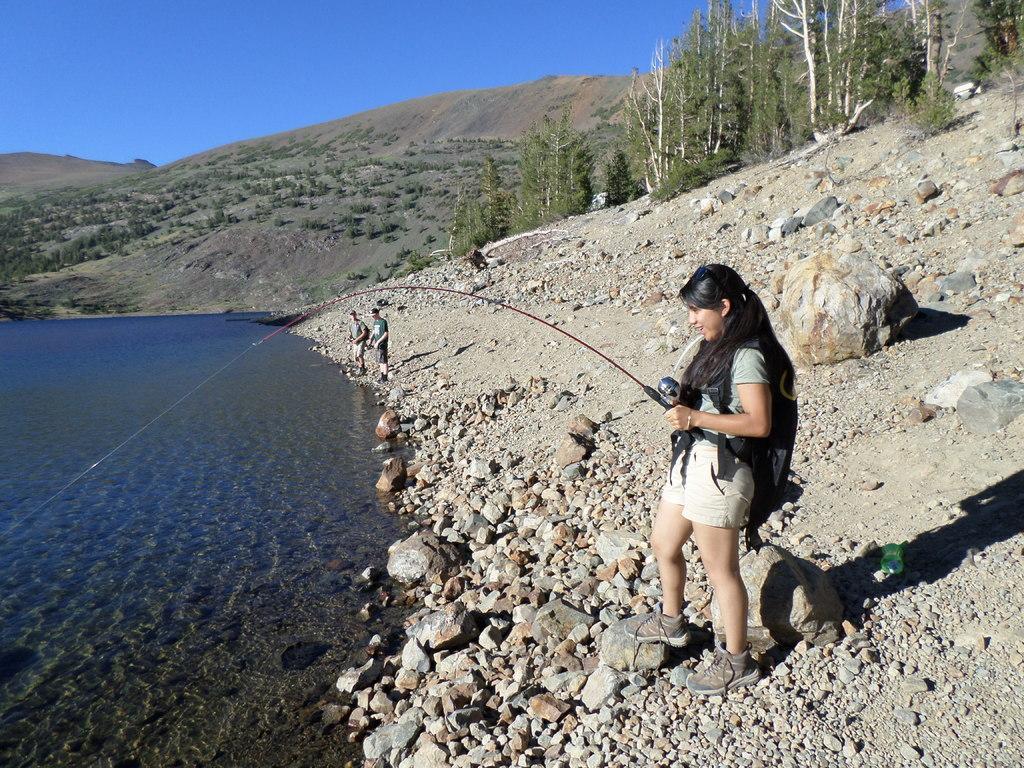Please provide a concise description of this image. This image consists of a girl fishing. At the bottom, there are rocks. In the background, there are two men standing near the water. On the right, there are small plants. In the background, there are mountains. At the top, there is sky. 